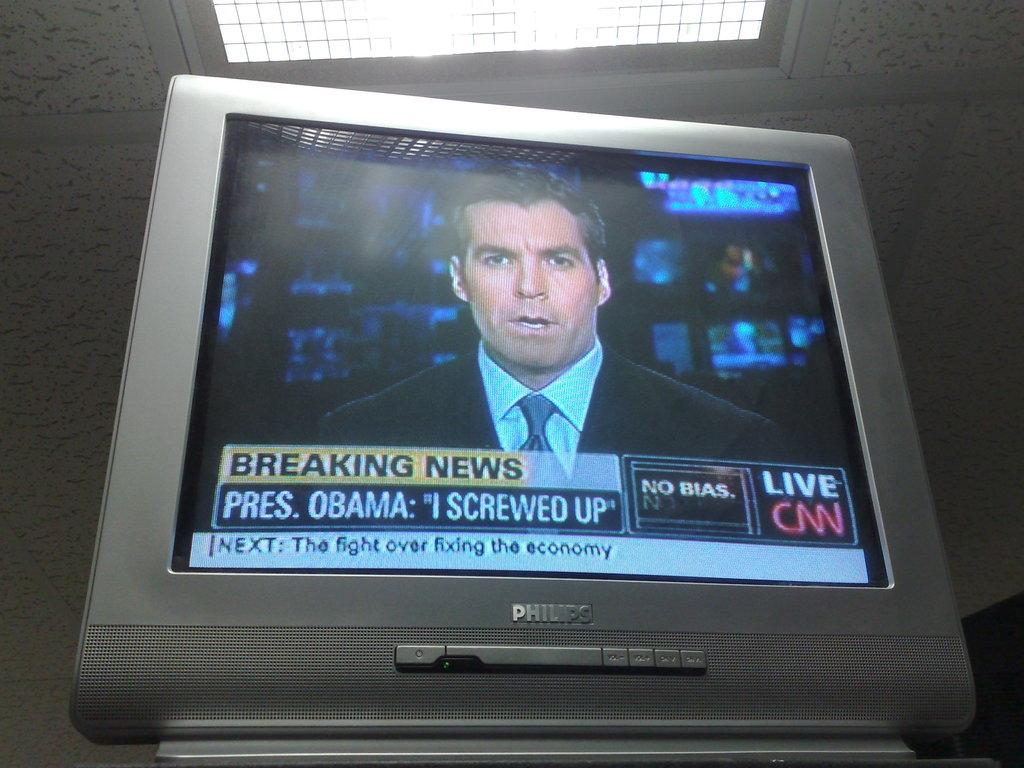Provide a one-sentence caption for the provided image. CNN is reporting that President Obama said he screwed up. 